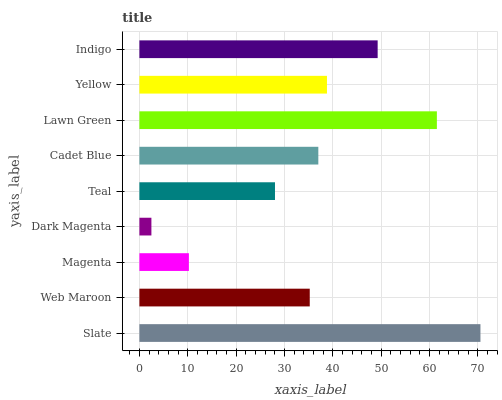Is Dark Magenta the minimum?
Answer yes or no. Yes. Is Slate the maximum?
Answer yes or no. Yes. Is Web Maroon the minimum?
Answer yes or no. No. Is Web Maroon the maximum?
Answer yes or no. No. Is Slate greater than Web Maroon?
Answer yes or no. Yes. Is Web Maroon less than Slate?
Answer yes or no. Yes. Is Web Maroon greater than Slate?
Answer yes or no. No. Is Slate less than Web Maroon?
Answer yes or no. No. Is Cadet Blue the high median?
Answer yes or no. Yes. Is Cadet Blue the low median?
Answer yes or no. Yes. Is Magenta the high median?
Answer yes or no. No. Is Dark Magenta the low median?
Answer yes or no. No. 